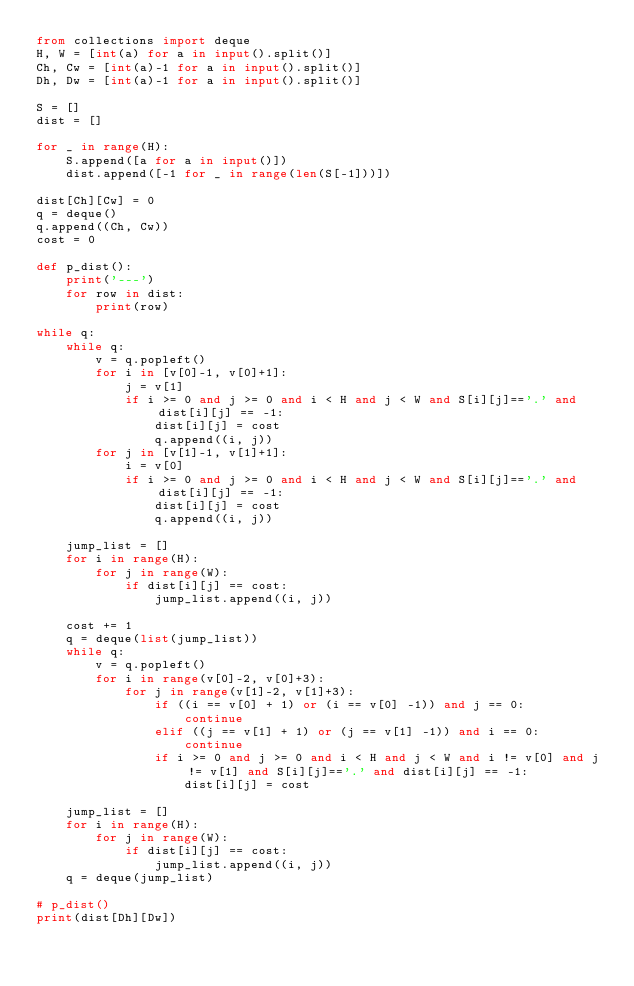Convert code to text. <code><loc_0><loc_0><loc_500><loc_500><_Python_>from collections import deque
H, W = [int(a) for a in input().split()]
Ch, Cw = [int(a)-1 for a in input().split()]
Dh, Dw = [int(a)-1 for a in input().split()]

S = []
dist = []

for _ in range(H):
    S.append([a for a in input()])
    dist.append([-1 for _ in range(len(S[-1]))])

dist[Ch][Cw] = 0
q = deque()
q.append((Ch, Cw))
cost = 0

def p_dist():
    print('---')
    for row in dist:
        print(row)

while q:
    while q:
        v = q.popleft()
        for i in [v[0]-1, v[0]+1]:
            j = v[1]
            if i >= 0 and j >= 0 and i < H and j < W and S[i][j]=='.' and dist[i][j] == -1:
                dist[i][j] = cost
                q.append((i, j))
        for j in [v[1]-1, v[1]+1]:
            i = v[0]
            if i >= 0 and j >= 0 and i < H and j < W and S[i][j]=='.' and dist[i][j] == -1:
                dist[i][j] = cost
                q.append((i, j))

    jump_list = []
    for i in range(H):
        for j in range(W):
            if dist[i][j] == cost:
                jump_list.append((i, j))

    cost += 1
    q = deque(list(jump_list))
    while q:
        v = q.popleft()
        for i in range(v[0]-2, v[0]+3):
            for j in range(v[1]-2, v[1]+3):
                if ((i == v[0] + 1) or (i == v[0] -1)) and j == 0:
                    continue
                elif ((j == v[1] + 1) or (j == v[1] -1)) and i == 0:
                    continue
                if i >= 0 and j >= 0 and i < H and j < W and i != v[0] and j != v[1] and S[i][j]=='.' and dist[i][j] == -1:
                    dist[i][j] = cost
    
    jump_list = []
    for i in range(H):
        for j in range(W):
            if dist[i][j] == cost:
                jump_list.append((i, j))
    q = deque(jump_list)

# p_dist()
print(dist[Dh][Dw])</code> 